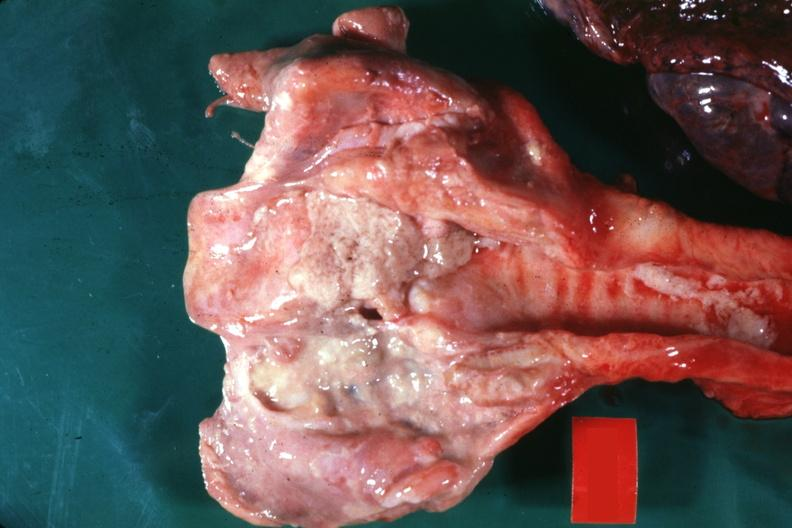s craniopharyngioma present?
Answer the question using a single word or phrase. No 